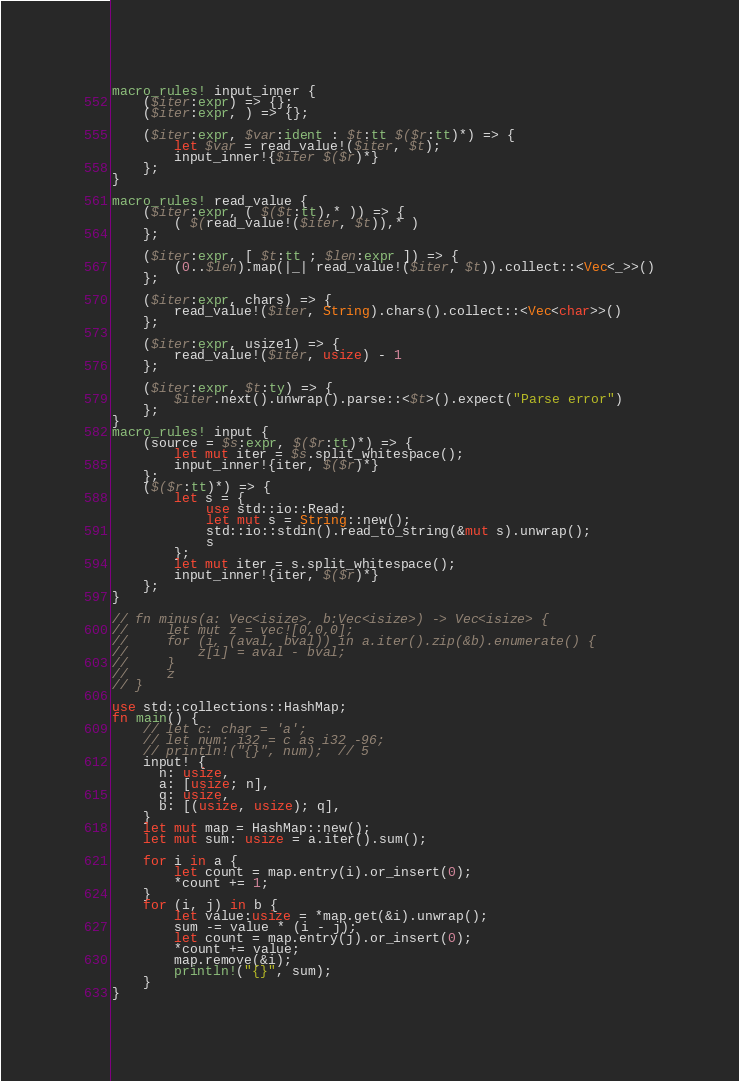Convert code to text. <code><loc_0><loc_0><loc_500><loc_500><_Rust_>macro_rules! input_inner {
    ($iter:expr) => {};
    ($iter:expr, ) => {};

    ($iter:expr, $var:ident : $t:tt $($r:tt)*) => {
        let $var = read_value!($iter, $t);
        input_inner!{$iter $($r)*}
    };
}

macro_rules! read_value {
    ($iter:expr, ( $($t:tt),* )) => {
        ( $(read_value!($iter, $t)),* )
    };

    ($iter:expr, [ $t:tt ; $len:expr ]) => {
        (0..$len).map(|_| read_value!($iter, $t)).collect::<Vec<_>>()
    };

    ($iter:expr, chars) => {
        read_value!($iter, String).chars().collect::<Vec<char>>()
    };

    ($iter:expr, usize1) => {
        read_value!($iter, usize) - 1
    };

    ($iter:expr, $t:ty) => {
        $iter.next().unwrap().parse::<$t>().expect("Parse error")
    };
}
macro_rules! input {
    (source = $s:expr, $($r:tt)*) => {
        let mut iter = $s.split_whitespace();
        input_inner!{iter, $($r)*}
    };
    ($($r:tt)*) => {
        let s = {
            use std::io::Read;
            let mut s = String::new();
            std::io::stdin().read_to_string(&mut s).unwrap();
            s
        };
        let mut iter = s.split_whitespace();
        input_inner!{iter, $($r)*}
    };
}

// fn minus(a: Vec<isize>, b:Vec<isize>) -> Vec<isize> {
//     let mut z = vec![0,0,0];
//     for (i, (aval, bval)) in a.iter().zip(&b).enumerate() {
//         z[i] = aval - bval;
//     }
//     z
// }

use std::collections::HashMap;
fn main() {
    // let c: char = 'a';
    // let num: i32 = c as i32 -96;
    // println!("{}", num);  // 5
    input! {
      n: usize,
      a: [usize; n],
      q: usize,
      b: [(usize, usize); q],
    }
    let mut map = HashMap::new();
    let mut sum: usize = a.iter().sum();

    for i in a {
        let count = map.entry(i).or_insert(0);
        *count += 1;
    }
    for (i, j) in b {
        let value:usize = *map.get(&i).unwrap();
        sum -= value * (i - j);
        let count = map.entry(j).or_insert(0);
        *count += value;
        map.remove(&i);
        println!("{}", sum);
    }
}</code> 